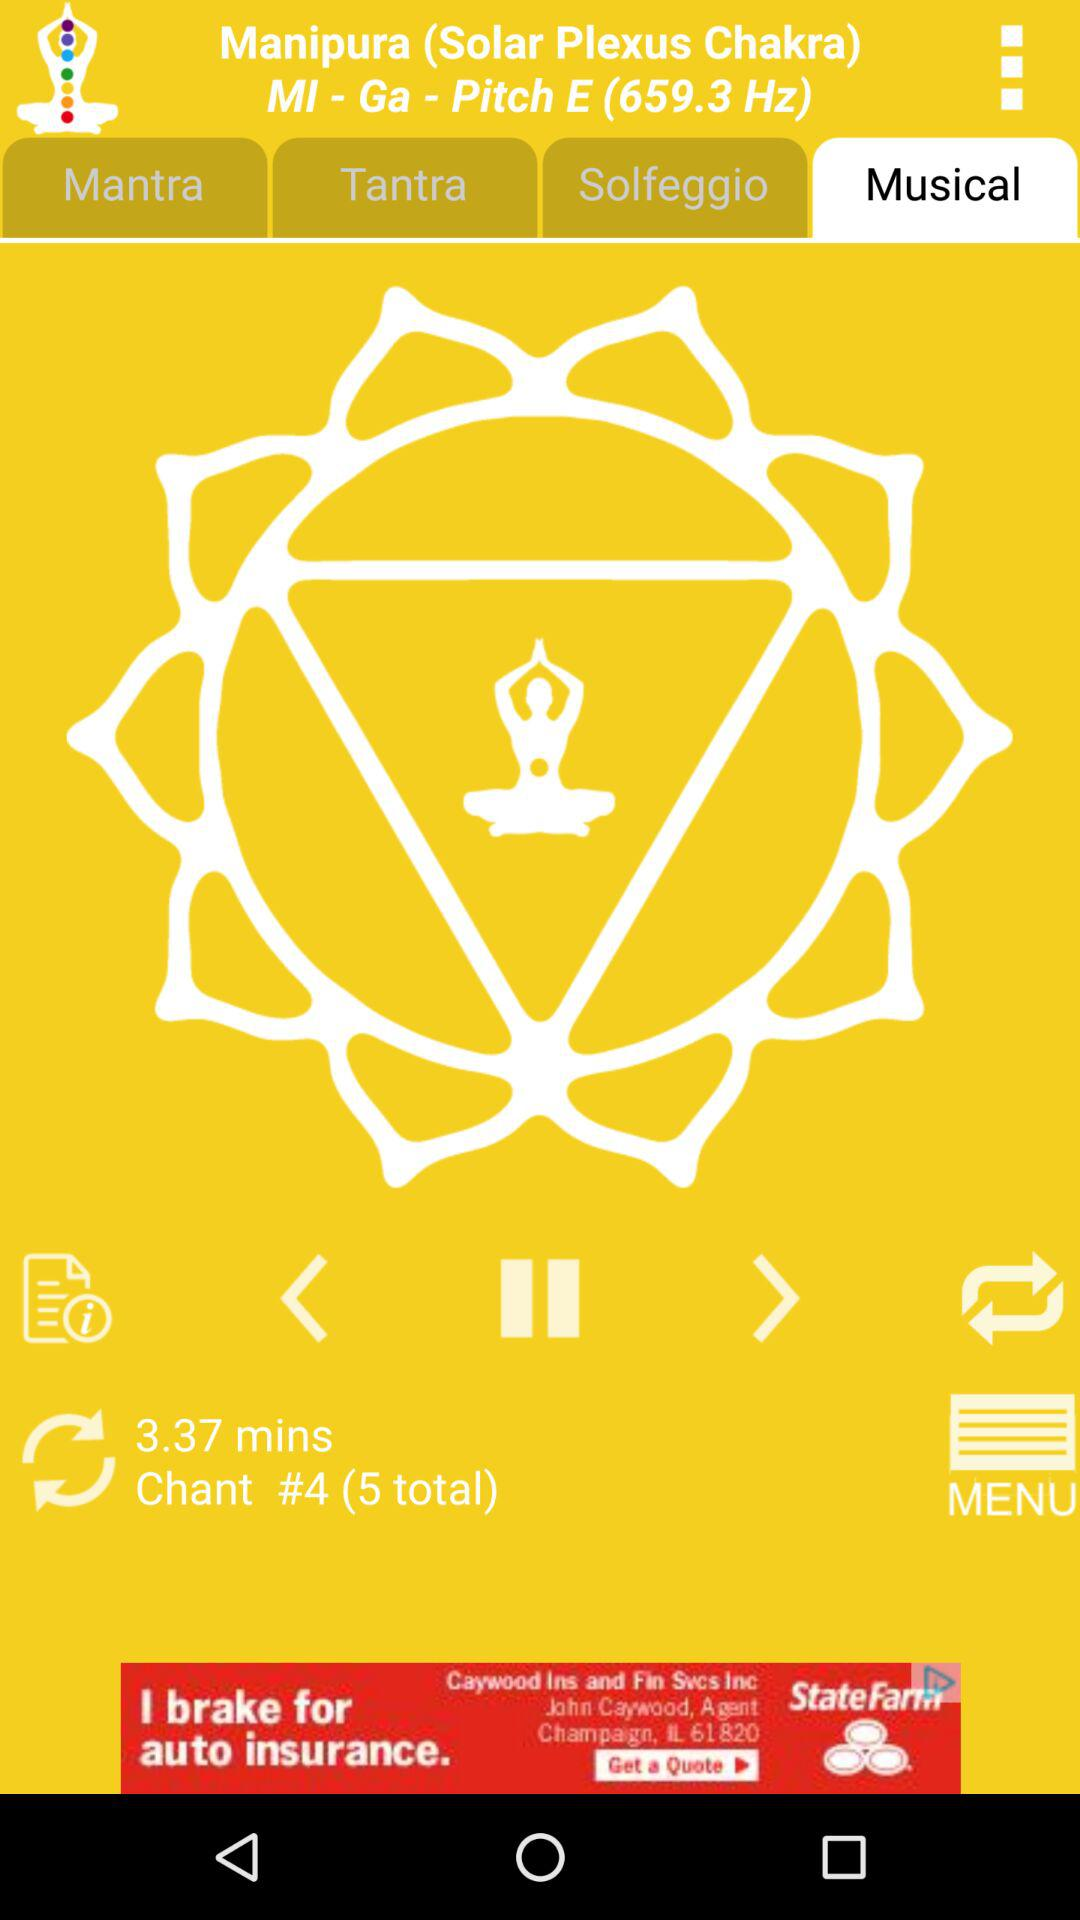What is the other name of Manipura? The other name of Manipura is "Solar Plexus Chakra". 